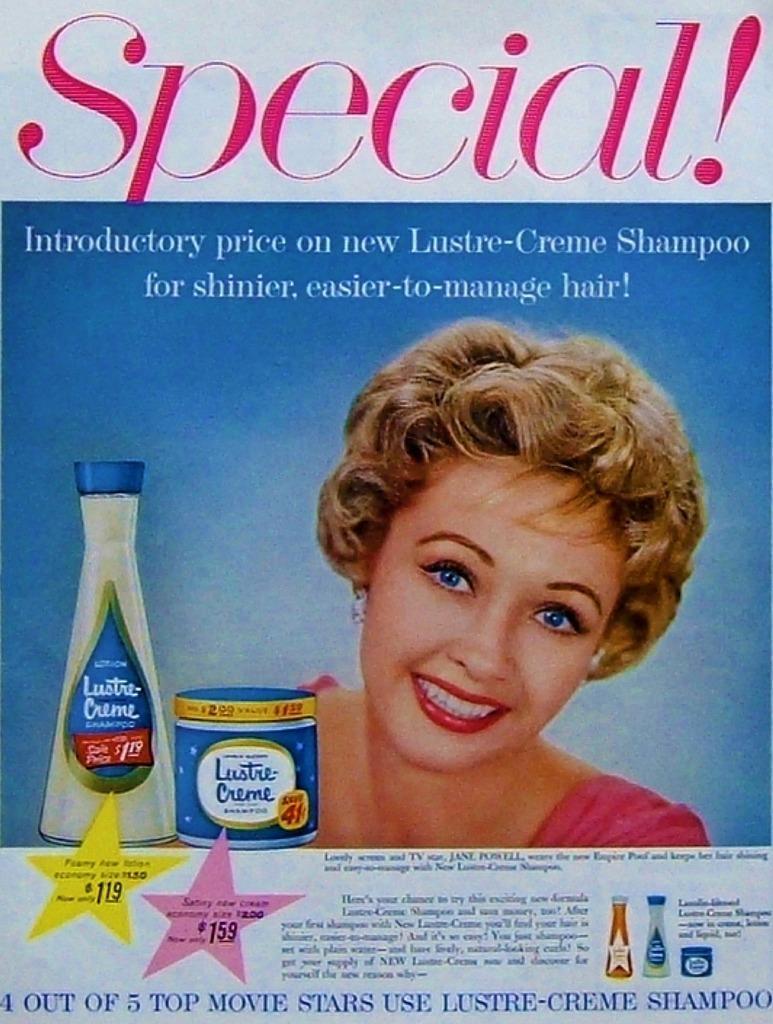Could you give a brief overview of what you see in this image? In this image, we can see a poster, on that poster we can see a picture of a woman, there is some text on the poster. 